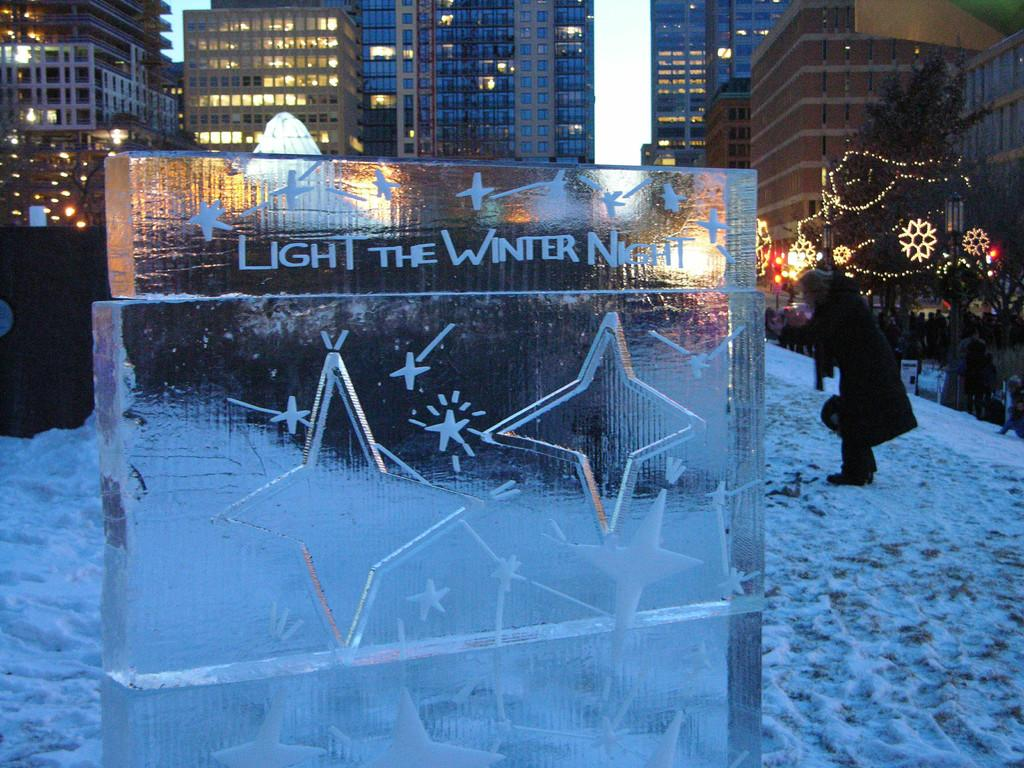What is the main subject of the image? There is an ice sculpture in the image. What can be seen in the background of the image? There are buildings, trees, and lights in the background of the image. Can you describe the person in the image? There is a person standing on the snow on the right side of the image. What type of wheel can be seen on the ice sculpture in the image? There is no wheel present on the ice sculpture in the image. How many cups of hot chocolate is the person holding in the image? There is no cup or hot chocolate visible in the image; the person is standing on the snow without any objects in their hands. 